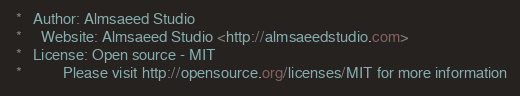Convert code to text. <code><loc_0><loc_0><loc_500><loc_500><_CSS_> *   Author: Almsaeed Studio
 *	 Website: Almsaeed Studio <http://almsaeedstudio.com>
 *   License: Open source - MIT
 *           Please visit http://opensource.org/licenses/MIT for more information</code> 